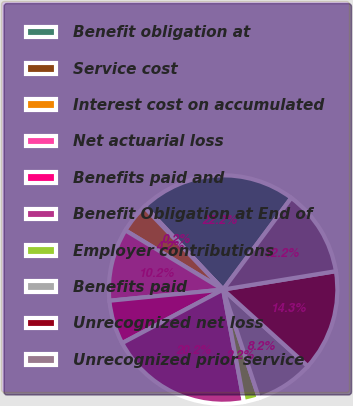Convert chart. <chart><loc_0><loc_0><loc_500><loc_500><pie_chart><fcel>Benefit obligation at<fcel>Service cost<fcel>Interest cost on accumulated<fcel>Net actuarial loss<fcel>Benefits paid and<fcel>Benefit Obligation at End of<fcel>Employer contributions<fcel>Benefits paid<fcel>Unrecognized net loss<fcel>Unrecognized prior service<nl><fcel>22.18%<fcel>0.15%<fcel>4.18%<fcel>10.23%<fcel>6.2%<fcel>20.16%<fcel>2.16%<fcel>8.22%<fcel>14.27%<fcel>12.25%<nl></chart> 